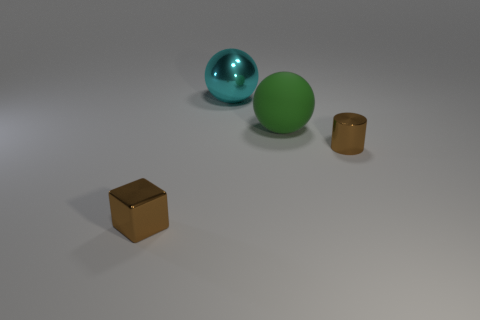Is there any other thing that is made of the same material as the green sphere?
Provide a short and direct response. No. Is there a brown cube that has the same material as the tiny brown cylinder?
Offer a terse response. Yes. The tiny object in front of the tiny brown thing on the right side of the big metallic thing is made of what material?
Provide a short and direct response. Metal. There is a object that is to the left of the green matte sphere and behind the small brown shiny cylinder; what is it made of?
Offer a very short reply. Metal. Is the number of green rubber balls that are right of the green object the same as the number of tiny green blocks?
Offer a terse response. Yes. What number of other large green matte things have the same shape as the green rubber object?
Ensure brevity in your answer.  0. What size is the brown shiny cylinder that is on the right side of the big metallic thing on the left side of the brown object that is on the right side of the brown block?
Make the answer very short. Small. Does the tiny brown thing that is right of the large green sphere have the same material as the cyan ball?
Provide a succinct answer. Yes. Are there an equal number of cylinders that are to the left of the metallic cube and big green matte spheres that are on the right side of the tiny metallic cylinder?
Your answer should be compact. Yes. There is another large thing that is the same shape as the big green thing; what is its material?
Provide a short and direct response. Metal. 